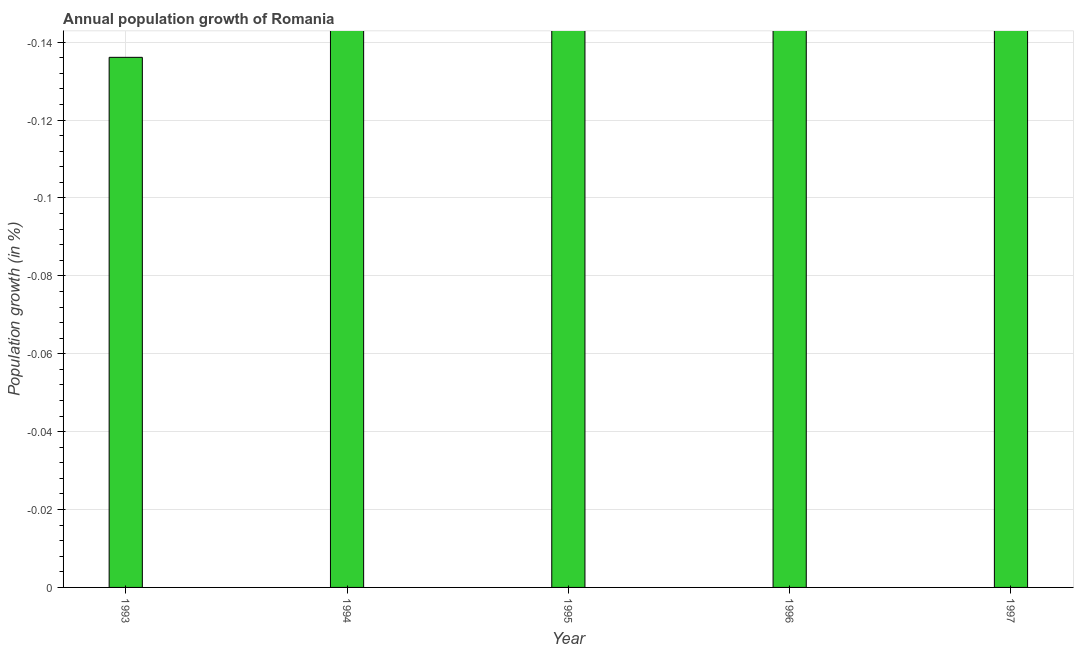Does the graph contain any zero values?
Your answer should be very brief. Yes. Does the graph contain grids?
Give a very brief answer. Yes. What is the title of the graph?
Keep it short and to the point. Annual population growth of Romania. What is the label or title of the Y-axis?
Your answer should be compact. Population growth (in %). What is the population growth in 1996?
Your answer should be very brief. 0. Across all years, what is the minimum population growth?
Offer a very short reply. 0. What is the median population growth?
Provide a succinct answer. 0. What is the difference between two consecutive major ticks on the Y-axis?
Keep it short and to the point. 0.02. Are the values on the major ticks of Y-axis written in scientific E-notation?
Offer a very short reply. No. What is the Population growth (in %) of 1993?
Ensure brevity in your answer.  0. What is the Population growth (in %) in 1994?
Ensure brevity in your answer.  0. 